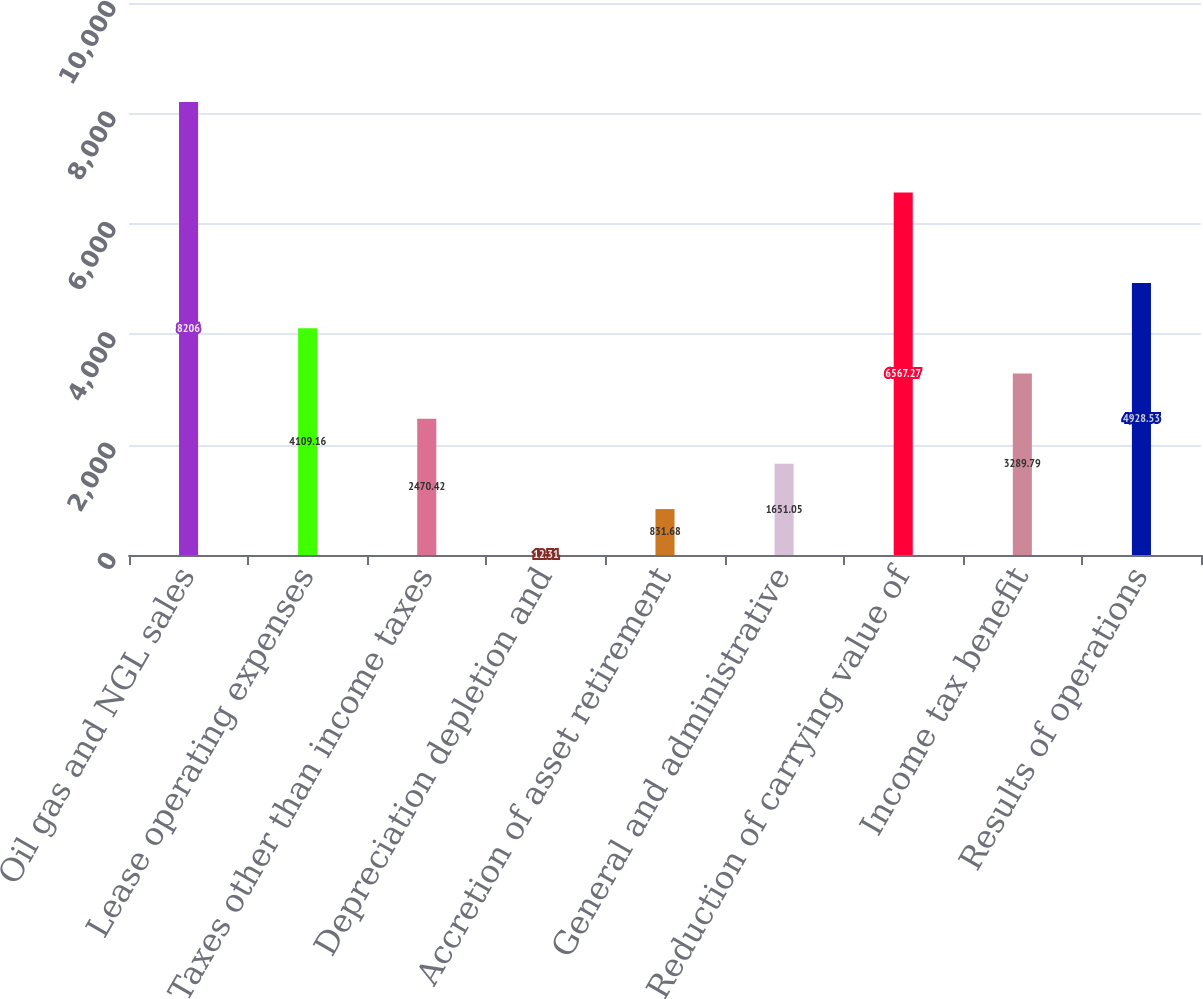Convert chart. <chart><loc_0><loc_0><loc_500><loc_500><bar_chart><fcel>Oil gas and NGL sales<fcel>Lease operating expenses<fcel>Taxes other than income taxes<fcel>Depreciation depletion and<fcel>Accretion of asset retirement<fcel>General and administrative<fcel>Reduction of carrying value of<fcel>Income tax benefit<fcel>Results of operations<nl><fcel>8206<fcel>4109.16<fcel>2470.42<fcel>12.31<fcel>831.68<fcel>1651.05<fcel>6567.27<fcel>3289.79<fcel>4928.53<nl></chart> 